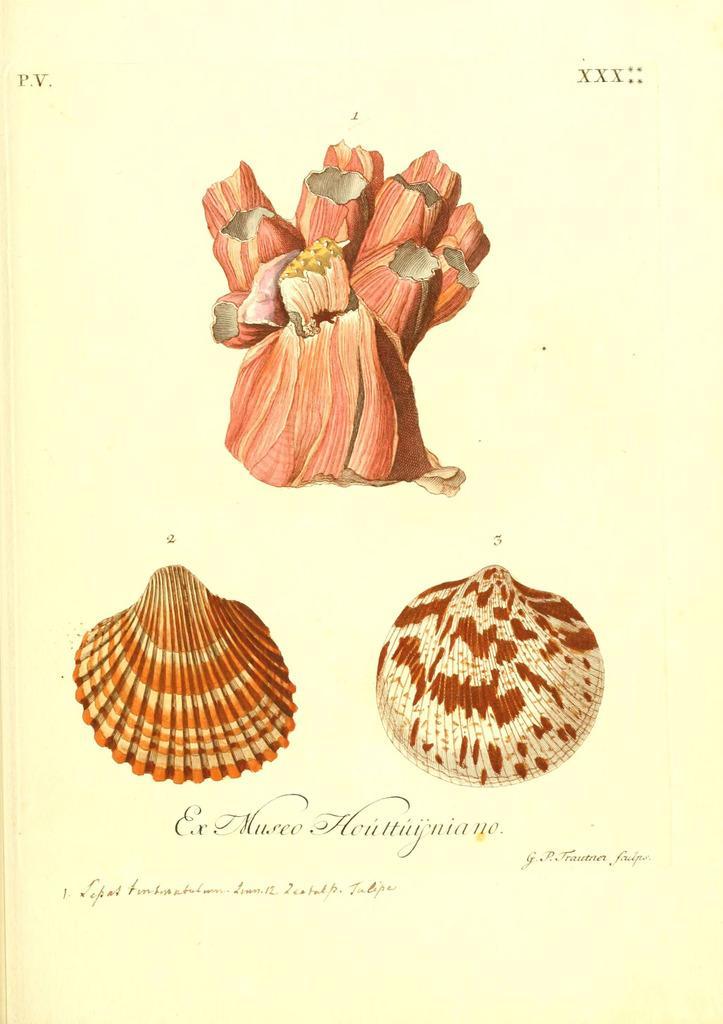How would you summarize this image in a sentence or two? This is a picture of a paper, where there are photos, words and roman numbers on it. 